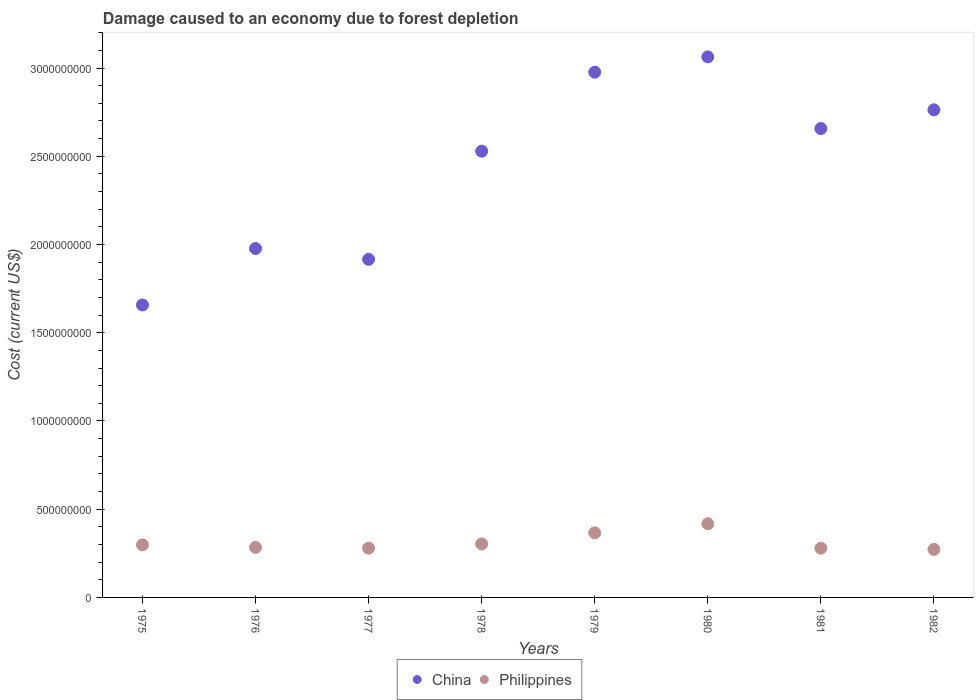How many different coloured dotlines are there?
Provide a succinct answer. 2. What is the cost of damage caused due to forest depletion in China in 1979?
Ensure brevity in your answer.  2.98e+09. Across all years, what is the maximum cost of damage caused due to forest depletion in Philippines?
Give a very brief answer. 4.17e+08. Across all years, what is the minimum cost of damage caused due to forest depletion in China?
Your answer should be very brief. 1.66e+09. In which year was the cost of damage caused due to forest depletion in China minimum?
Your answer should be very brief. 1975. What is the total cost of damage caused due to forest depletion in China in the graph?
Give a very brief answer. 1.95e+1. What is the difference between the cost of damage caused due to forest depletion in China in 1975 and that in 1979?
Provide a succinct answer. -1.32e+09. What is the difference between the cost of damage caused due to forest depletion in China in 1981 and the cost of damage caused due to forest depletion in Philippines in 1980?
Offer a terse response. 2.24e+09. What is the average cost of damage caused due to forest depletion in Philippines per year?
Your answer should be very brief. 3.12e+08. In the year 1982, what is the difference between the cost of damage caused due to forest depletion in Philippines and cost of damage caused due to forest depletion in China?
Offer a very short reply. -2.49e+09. In how many years, is the cost of damage caused due to forest depletion in China greater than 2400000000 US$?
Give a very brief answer. 5. What is the ratio of the cost of damage caused due to forest depletion in China in 1977 to that in 1981?
Your answer should be compact. 0.72. Is the difference between the cost of damage caused due to forest depletion in Philippines in 1976 and 1981 greater than the difference between the cost of damage caused due to forest depletion in China in 1976 and 1981?
Ensure brevity in your answer.  Yes. What is the difference between the highest and the second highest cost of damage caused due to forest depletion in China?
Make the answer very short. 8.67e+07. What is the difference between the highest and the lowest cost of damage caused due to forest depletion in Philippines?
Provide a short and direct response. 1.45e+08. Does the cost of damage caused due to forest depletion in China monotonically increase over the years?
Ensure brevity in your answer.  No. Is the cost of damage caused due to forest depletion in Philippines strictly greater than the cost of damage caused due to forest depletion in China over the years?
Provide a succinct answer. No. Is the cost of damage caused due to forest depletion in China strictly less than the cost of damage caused due to forest depletion in Philippines over the years?
Make the answer very short. No. What is the difference between two consecutive major ticks on the Y-axis?
Your answer should be very brief. 5.00e+08. Does the graph contain any zero values?
Ensure brevity in your answer.  No. What is the title of the graph?
Your response must be concise. Damage caused to an economy due to forest depletion. What is the label or title of the Y-axis?
Provide a short and direct response. Cost (current US$). What is the Cost (current US$) of China in 1975?
Your answer should be very brief. 1.66e+09. What is the Cost (current US$) of Philippines in 1975?
Keep it short and to the point. 2.98e+08. What is the Cost (current US$) of China in 1976?
Keep it short and to the point. 1.98e+09. What is the Cost (current US$) in Philippines in 1976?
Your answer should be compact. 2.84e+08. What is the Cost (current US$) in China in 1977?
Your answer should be very brief. 1.92e+09. What is the Cost (current US$) of Philippines in 1977?
Provide a short and direct response. 2.79e+08. What is the Cost (current US$) in China in 1978?
Provide a succinct answer. 2.53e+09. What is the Cost (current US$) in Philippines in 1978?
Your answer should be compact. 3.03e+08. What is the Cost (current US$) of China in 1979?
Ensure brevity in your answer.  2.98e+09. What is the Cost (current US$) in Philippines in 1979?
Provide a short and direct response. 3.66e+08. What is the Cost (current US$) in China in 1980?
Ensure brevity in your answer.  3.06e+09. What is the Cost (current US$) in Philippines in 1980?
Keep it short and to the point. 4.17e+08. What is the Cost (current US$) in China in 1981?
Make the answer very short. 2.66e+09. What is the Cost (current US$) in Philippines in 1981?
Your response must be concise. 2.79e+08. What is the Cost (current US$) in China in 1982?
Make the answer very short. 2.76e+09. What is the Cost (current US$) of Philippines in 1982?
Your response must be concise. 2.72e+08. Across all years, what is the maximum Cost (current US$) of China?
Offer a very short reply. 3.06e+09. Across all years, what is the maximum Cost (current US$) of Philippines?
Your answer should be very brief. 4.17e+08. Across all years, what is the minimum Cost (current US$) of China?
Provide a short and direct response. 1.66e+09. Across all years, what is the minimum Cost (current US$) in Philippines?
Provide a succinct answer. 2.72e+08. What is the total Cost (current US$) of China in the graph?
Offer a very short reply. 1.95e+1. What is the total Cost (current US$) of Philippines in the graph?
Ensure brevity in your answer.  2.50e+09. What is the difference between the Cost (current US$) in China in 1975 and that in 1976?
Ensure brevity in your answer.  -3.20e+08. What is the difference between the Cost (current US$) of Philippines in 1975 and that in 1976?
Offer a very short reply. 1.45e+07. What is the difference between the Cost (current US$) of China in 1975 and that in 1977?
Keep it short and to the point. -2.59e+08. What is the difference between the Cost (current US$) of Philippines in 1975 and that in 1977?
Your response must be concise. 1.87e+07. What is the difference between the Cost (current US$) in China in 1975 and that in 1978?
Make the answer very short. -8.72e+08. What is the difference between the Cost (current US$) in Philippines in 1975 and that in 1978?
Ensure brevity in your answer.  -4.94e+06. What is the difference between the Cost (current US$) in China in 1975 and that in 1979?
Offer a terse response. -1.32e+09. What is the difference between the Cost (current US$) in Philippines in 1975 and that in 1979?
Provide a succinct answer. -6.81e+07. What is the difference between the Cost (current US$) in China in 1975 and that in 1980?
Your answer should be very brief. -1.41e+09. What is the difference between the Cost (current US$) of Philippines in 1975 and that in 1980?
Give a very brief answer. -1.19e+08. What is the difference between the Cost (current US$) in China in 1975 and that in 1981?
Offer a very short reply. -1.00e+09. What is the difference between the Cost (current US$) in Philippines in 1975 and that in 1981?
Ensure brevity in your answer.  1.90e+07. What is the difference between the Cost (current US$) in China in 1975 and that in 1982?
Offer a terse response. -1.11e+09. What is the difference between the Cost (current US$) of Philippines in 1975 and that in 1982?
Give a very brief answer. 2.59e+07. What is the difference between the Cost (current US$) in China in 1976 and that in 1977?
Make the answer very short. 6.12e+07. What is the difference between the Cost (current US$) of Philippines in 1976 and that in 1977?
Provide a succinct answer. 4.23e+06. What is the difference between the Cost (current US$) in China in 1976 and that in 1978?
Your answer should be compact. -5.52e+08. What is the difference between the Cost (current US$) of Philippines in 1976 and that in 1978?
Ensure brevity in your answer.  -1.94e+07. What is the difference between the Cost (current US$) in China in 1976 and that in 1979?
Provide a short and direct response. -9.99e+08. What is the difference between the Cost (current US$) of Philippines in 1976 and that in 1979?
Offer a terse response. -8.25e+07. What is the difference between the Cost (current US$) in China in 1976 and that in 1980?
Your response must be concise. -1.09e+09. What is the difference between the Cost (current US$) of Philippines in 1976 and that in 1980?
Your response must be concise. -1.34e+08. What is the difference between the Cost (current US$) in China in 1976 and that in 1981?
Provide a succinct answer. -6.80e+08. What is the difference between the Cost (current US$) in Philippines in 1976 and that in 1981?
Ensure brevity in your answer.  4.59e+06. What is the difference between the Cost (current US$) of China in 1976 and that in 1982?
Your answer should be very brief. -7.86e+08. What is the difference between the Cost (current US$) of Philippines in 1976 and that in 1982?
Your answer should be compact. 1.15e+07. What is the difference between the Cost (current US$) of China in 1977 and that in 1978?
Your answer should be very brief. -6.13e+08. What is the difference between the Cost (current US$) of Philippines in 1977 and that in 1978?
Offer a very short reply. -2.36e+07. What is the difference between the Cost (current US$) in China in 1977 and that in 1979?
Ensure brevity in your answer.  -1.06e+09. What is the difference between the Cost (current US$) of Philippines in 1977 and that in 1979?
Your answer should be very brief. -8.68e+07. What is the difference between the Cost (current US$) of China in 1977 and that in 1980?
Offer a terse response. -1.15e+09. What is the difference between the Cost (current US$) of Philippines in 1977 and that in 1980?
Offer a terse response. -1.38e+08. What is the difference between the Cost (current US$) of China in 1977 and that in 1981?
Ensure brevity in your answer.  -7.41e+08. What is the difference between the Cost (current US$) in Philippines in 1977 and that in 1981?
Provide a short and direct response. 3.63e+05. What is the difference between the Cost (current US$) of China in 1977 and that in 1982?
Ensure brevity in your answer.  -8.47e+08. What is the difference between the Cost (current US$) of Philippines in 1977 and that in 1982?
Offer a terse response. 7.22e+06. What is the difference between the Cost (current US$) in China in 1978 and that in 1979?
Offer a very short reply. -4.48e+08. What is the difference between the Cost (current US$) in Philippines in 1978 and that in 1979?
Ensure brevity in your answer.  -6.31e+07. What is the difference between the Cost (current US$) of China in 1978 and that in 1980?
Your response must be concise. -5.34e+08. What is the difference between the Cost (current US$) of Philippines in 1978 and that in 1980?
Offer a terse response. -1.14e+08. What is the difference between the Cost (current US$) of China in 1978 and that in 1981?
Provide a short and direct response. -1.28e+08. What is the difference between the Cost (current US$) in Philippines in 1978 and that in 1981?
Provide a short and direct response. 2.40e+07. What is the difference between the Cost (current US$) in China in 1978 and that in 1982?
Provide a short and direct response. -2.34e+08. What is the difference between the Cost (current US$) in Philippines in 1978 and that in 1982?
Provide a short and direct response. 3.08e+07. What is the difference between the Cost (current US$) in China in 1979 and that in 1980?
Offer a terse response. -8.67e+07. What is the difference between the Cost (current US$) in Philippines in 1979 and that in 1980?
Ensure brevity in your answer.  -5.13e+07. What is the difference between the Cost (current US$) of China in 1979 and that in 1981?
Offer a very short reply. 3.19e+08. What is the difference between the Cost (current US$) of Philippines in 1979 and that in 1981?
Keep it short and to the point. 8.71e+07. What is the difference between the Cost (current US$) in China in 1979 and that in 1982?
Keep it short and to the point. 2.13e+08. What is the difference between the Cost (current US$) in Philippines in 1979 and that in 1982?
Your answer should be compact. 9.40e+07. What is the difference between the Cost (current US$) of China in 1980 and that in 1981?
Your answer should be compact. 4.06e+08. What is the difference between the Cost (current US$) of Philippines in 1980 and that in 1981?
Keep it short and to the point. 1.38e+08. What is the difference between the Cost (current US$) in China in 1980 and that in 1982?
Your response must be concise. 3.00e+08. What is the difference between the Cost (current US$) of Philippines in 1980 and that in 1982?
Provide a short and direct response. 1.45e+08. What is the difference between the Cost (current US$) of China in 1981 and that in 1982?
Offer a terse response. -1.06e+08. What is the difference between the Cost (current US$) of Philippines in 1981 and that in 1982?
Ensure brevity in your answer.  6.86e+06. What is the difference between the Cost (current US$) of China in 1975 and the Cost (current US$) of Philippines in 1976?
Make the answer very short. 1.37e+09. What is the difference between the Cost (current US$) of China in 1975 and the Cost (current US$) of Philippines in 1977?
Your response must be concise. 1.38e+09. What is the difference between the Cost (current US$) in China in 1975 and the Cost (current US$) in Philippines in 1978?
Make the answer very short. 1.35e+09. What is the difference between the Cost (current US$) of China in 1975 and the Cost (current US$) of Philippines in 1979?
Offer a very short reply. 1.29e+09. What is the difference between the Cost (current US$) in China in 1975 and the Cost (current US$) in Philippines in 1980?
Your answer should be very brief. 1.24e+09. What is the difference between the Cost (current US$) of China in 1975 and the Cost (current US$) of Philippines in 1981?
Provide a succinct answer. 1.38e+09. What is the difference between the Cost (current US$) in China in 1975 and the Cost (current US$) in Philippines in 1982?
Your response must be concise. 1.39e+09. What is the difference between the Cost (current US$) of China in 1976 and the Cost (current US$) of Philippines in 1977?
Ensure brevity in your answer.  1.70e+09. What is the difference between the Cost (current US$) in China in 1976 and the Cost (current US$) in Philippines in 1978?
Keep it short and to the point. 1.67e+09. What is the difference between the Cost (current US$) of China in 1976 and the Cost (current US$) of Philippines in 1979?
Keep it short and to the point. 1.61e+09. What is the difference between the Cost (current US$) in China in 1976 and the Cost (current US$) in Philippines in 1980?
Offer a very short reply. 1.56e+09. What is the difference between the Cost (current US$) in China in 1976 and the Cost (current US$) in Philippines in 1981?
Offer a very short reply. 1.70e+09. What is the difference between the Cost (current US$) in China in 1976 and the Cost (current US$) in Philippines in 1982?
Your response must be concise. 1.71e+09. What is the difference between the Cost (current US$) in China in 1977 and the Cost (current US$) in Philippines in 1978?
Your response must be concise. 1.61e+09. What is the difference between the Cost (current US$) in China in 1977 and the Cost (current US$) in Philippines in 1979?
Make the answer very short. 1.55e+09. What is the difference between the Cost (current US$) of China in 1977 and the Cost (current US$) of Philippines in 1980?
Your answer should be compact. 1.50e+09. What is the difference between the Cost (current US$) in China in 1977 and the Cost (current US$) in Philippines in 1981?
Offer a terse response. 1.64e+09. What is the difference between the Cost (current US$) in China in 1977 and the Cost (current US$) in Philippines in 1982?
Ensure brevity in your answer.  1.64e+09. What is the difference between the Cost (current US$) of China in 1978 and the Cost (current US$) of Philippines in 1979?
Offer a very short reply. 2.16e+09. What is the difference between the Cost (current US$) in China in 1978 and the Cost (current US$) in Philippines in 1980?
Offer a very short reply. 2.11e+09. What is the difference between the Cost (current US$) of China in 1978 and the Cost (current US$) of Philippines in 1981?
Offer a terse response. 2.25e+09. What is the difference between the Cost (current US$) of China in 1978 and the Cost (current US$) of Philippines in 1982?
Provide a short and direct response. 2.26e+09. What is the difference between the Cost (current US$) in China in 1979 and the Cost (current US$) in Philippines in 1980?
Your response must be concise. 2.56e+09. What is the difference between the Cost (current US$) of China in 1979 and the Cost (current US$) of Philippines in 1981?
Your answer should be compact. 2.70e+09. What is the difference between the Cost (current US$) of China in 1979 and the Cost (current US$) of Philippines in 1982?
Keep it short and to the point. 2.70e+09. What is the difference between the Cost (current US$) in China in 1980 and the Cost (current US$) in Philippines in 1981?
Offer a terse response. 2.78e+09. What is the difference between the Cost (current US$) in China in 1980 and the Cost (current US$) in Philippines in 1982?
Offer a very short reply. 2.79e+09. What is the difference between the Cost (current US$) in China in 1981 and the Cost (current US$) in Philippines in 1982?
Give a very brief answer. 2.39e+09. What is the average Cost (current US$) of China per year?
Provide a succinct answer. 2.44e+09. What is the average Cost (current US$) in Philippines per year?
Offer a terse response. 3.12e+08. In the year 1975, what is the difference between the Cost (current US$) in China and Cost (current US$) in Philippines?
Your answer should be very brief. 1.36e+09. In the year 1976, what is the difference between the Cost (current US$) of China and Cost (current US$) of Philippines?
Keep it short and to the point. 1.69e+09. In the year 1977, what is the difference between the Cost (current US$) in China and Cost (current US$) in Philippines?
Make the answer very short. 1.64e+09. In the year 1978, what is the difference between the Cost (current US$) in China and Cost (current US$) in Philippines?
Make the answer very short. 2.23e+09. In the year 1979, what is the difference between the Cost (current US$) of China and Cost (current US$) of Philippines?
Make the answer very short. 2.61e+09. In the year 1980, what is the difference between the Cost (current US$) in China and Cost (current US$) in Philippines?
Provide a succinct answer. 2.65e+09. In the year 1981, what is the difference between the Cost (current US$) in China and Cost (current US$) in Philippines?
Give a very brief answer. 2.38e+09. In the year 1982, what is the difference between the Cost (current US$) of China and Cost (current US$) of Philippines?
Keep it short and to the point. 2.49e+09. What is the ratio of the Cost (current US$) in China in 1975 to that in 1976?
Ensure brevity in your answer.  0.84. What is the ratio of the Cost (current US$) of Philippines in 1975 to that in 1976?
Provide a short and direct response. 1.05. What is the ratio of the Cost (current US$) of China in 1975 to that in 1977?
Ensure brevity in your answer.  0.86. What is the ratio of the Cost (current US$) in Philippines in 1975 to that in 1977?
Provide a short and direct response. 1.07. What is the ratio of the Cost (current US$) of China in 1975 to that in 1978?
Offer a very short reply. 0.66. What is the ratio of the Cost (current US$) in Philippines in 1975 to that in 1978?
Keep it short and to the point. 0.98. What is the ratio of the Cost (current US$) of China in 1975 to that in 1979?
Your response must be concise. 0.56. What is the ratio of the Cost (current US$) in Philippines in 1975 to that in 1979?
Keep it short and to the point. 0.81. What is the ratio of the Cost (current US$) in China in 1975 to that in 1980?
Your answer should be very brief. 0.54. What is the ratio of the Cost (current US$) of Philippines in 1975 to that in 1980?
Make the answer very short. 0.71. What is the ratio of the Cost (current US$) of China in 1975 to that in 1981?
Provide a short and direct response. 0.62. What is the ratio of the Cost (current US$) in Philippines in 1975 to that in 1981?
Offer a terse response. 1.07. What is the ratio of the Cost (current US$) of China in 1975 to that in 1982?
Offer a very short reply. 0.6. What is the ratio of the Cost (current US$) of Philippines in 1975 to that in 1982?
Your answer should be compact. 1.1. What is the ratio of the Cost (current US$) of China in 1976 to that in 1977?
Give a very brief answer. 1.03. What is the ratio of the Cost (current US$) of Philippines in 1976 to that in 1977?
Provide a succinct answer. 1.02. What is the ratio of the Cost (current US$) in China in 1976 to that in 1978?
Keep it short and to the point. 0.78. What is the ratio of the Cost (current US$) in Philippines in 1976 to that in 1978?
Your answer should be compact. 0.94. What is the ratio of the Cost (current US$) of China in 1976 to that in 1979?
Provide a succinct answer. 0.66. What is the ratio of the Cost (current US$) of Philippines in 1976 to that in 1979?
Provide a short and direct response. 0.77. What is the ratio of the Cost (current US$) in China in 1976 to that in 1980?
Provide a succinct answer. 0.65. What is the ratio of the Cost (current US$) in Philippines in 1976 to that in 1980?
Provide a short and direct response. 0.68. What is the ratio of the Cost (current US$) of China in 1976 to that in 1981?
Offer a terse response. 0.74. What is the ratio of the Cost (current US$) of Philippines in 1976 to that in 1981?
Your response must be concise. 1.02. What is the ratio of the Cost (current US$) in China in 1976 to that in 1982?
Provide a succinct answer. 0.72. What is the ratio of the Cost (current US$) of Philippines in 1976 to that in 1982?
Keep it short and to the point. 1.04. What is the ratio of the Cost (current US$) in China in 1977 to that in 1978?
Ensure brevity in your answer.  0.76. What is the ratio of the Cost (current US$) of Philippines in 1977 to that in 1978?
Give a very brief answer. 0.92. What is the ratio of the Cost (current US$) in China in 1977 to that in 1979?
Provide a succinct answer. 0.64. What is the ratio of the Cost (current US$) of Philippines in 1977 to that in 1979?
Your answer should be compact. 0.76. What is the ratio of the Cost (current US$) of China in 1977 to that in 1980?
Make the answer very short. 0.63. What is the ratio of the Cost (current US$) of Philippines in 1977 to that in 1980?
Provide a succinct answer. 0.67. What is the ratio of the Cost (current US$) of China in 1977 to that in 1981?
Keep it short and to the point. 0.72. What is the ratio of the Cost (current US$) of China in 1977 to that in 1982?
Keep it short and to the point. 0.69. What is the ratio of the Cost (current US$) in Philippines in 1977 to that in 1982?
Your response must be concise. 1.03. What is the ratio of the Cost (current US$) in China in 1978 to that in 1979?
Give a very brief answer. 0.85. What is the ratio of the Cost (current US$) of Philippines in 1978 to that in 1979?
Your answer should be compact. 0.83. What is the ratio of the Cost (current US$) of China in 1978 to that in 1980?
Provide a short and direct response. 0.83. What is the ratio of the Cost (current US$) in Philippines in 1978 to that in 1980?
Make the answer very short. 0.73. What is the ratio of the Cost (current US$) in China in 1978 to that in 1981?
Offer a terse response. 0.95. What is the ratio of the Cost (current US$) in Philippines in 1978 to that in 1981?
Provide a succinct answer. 1.09. What is the ratio of the Cost (current US$) of China in 1978 to that in 1982?
Provide a short and direct response. 0.92. What is the ratio of the Cost (current US$) of Philippines in 1978 to that in 1982?
Make the answer very short. 1.11. What is the ratio of the Cost (current US$) of China in 1979 to that in 1980?
Give a very brief answer. 0.97. What is the ratio of the Cost (current US$) of Philippines in 1979 to that in 1980?
Your answer should be very brief. 0.88. What is the ratio of the Cost (current US$) in China in 1979 to that in 1981?
Ensure brevity in your answer.  1.12. What is the ratio of the Cost (current US$) of Philippines in 1979 to that in 1981?
Your answer should be very brief. 1.31. What is the ratio of the Cost (current US$) in China in 1979 to that in 1982?
Your response must be concise. 1.08. What is the ratio of the Cost (current US$) of Philippines in 1979 to that in 1982?
Make the answer very short. 1.35. What is the ratio of the Cost (current US$) of China in 1980 to that in 1981?
Give a very brief answer. 1.15. What is the ratio of the Cost (current US$) in Philippines in 1980 to that in 1981?
Your response must be concise. 1.5. What is the ratio of the Cost (current US$) of China in 1980 to that in 1982?
Your answer should be compact. 1.11. What is the ratio of the Cost (current US$) of Philippines in 1980 to that in 1982?
Provide a short and direct response. 1.53. What is the ratio of the Cost (current US$) in China in 1981 to that in 1982?
Offer a terse response. 0.96. What is the ratio of the Cost (current US$) of Philippines in 1981 to that in 1982?
Provide a short and direct response. 1.03. What is the difference between the highest and the second highest Cost (current US$) of China?
Your answer should be very brief. 8.67e+07. What is the difference between the highest and the second highest Cost (current US$) in Philippines?
Your answer should be compact. 5.13e+07. What is the difference between the highest and the lowest Cost (current US$) of China?
Your answer should be very brief. 1.41e+09. What is the difference between the highest and the lowest Cost (current US$) in Philippines?
Offer a very short reply. 1.45e+08. 